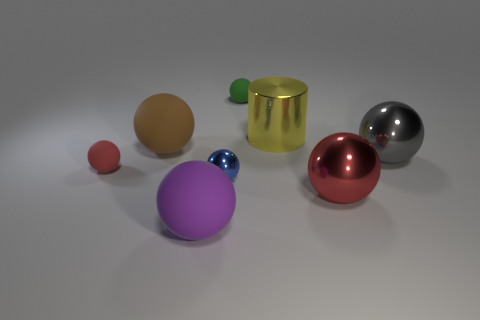Does the large gray object have the same shape as the tiny green object?
Give a very brief answer. Yes. How many large things are both in front of the large cylinder and right of the green thing?
Offer a terse response. 2. How many rubber objects are yellow cylinders or red spheres?
Keep it short and to the point. 1. There is a red object in front of the small red matte sphere on the left side of the yellow metallic cylinder; what is its size?
Provide a succinct answer. Large. Is there a small blue shiny ball on the right side of the small rubber object that is to the left of the small thing behind the big yellow metal thing?
Offer a very short reply. Yes. Is the material of the red thing that is right of the tiny green rubber ball the same as the red object left of the tiny blue shiny object?
Offer a very short reply. No. What number of things are either tiny green matte spheres or objects that are left of the small green thing?
Provide a short and direct response. 5. What number of other yellow things have the same shape as the big yellow thing?
Offer a terse response. 0. What material is the brown sphere that is the same size as the gray shiny ball?
Your answer should be very brief. Rubber. How big is the red ball to the left of the big metal object in front of the red thing behind the small shiny sphere?
Your answer should be compact. Small. 